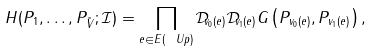Convert formula to latex. <formula><loc_0><loc_0><loc_500><loc_500>H ( P _ { 1 } , \dots , P _ { \tilde { V } } ; \mathcal { I } ) = \prod _ { e \in E ( \ U p ) } \mathcal { D } _ { v _ { 0 } ( e ) } \mathcal { D } _ { v _ { 1 } ( e ) } G \left ( P _ { v _ { 0 } ( e ) } , P _ { v _ { 1 } ( e ) } \right ) ,</formula> 